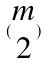Convert formula to latex. <formula><loc_0><loc_0><loc_500><loc_500>( \begin{matrix} m \\ 2 \end{matrix} )</formula> 